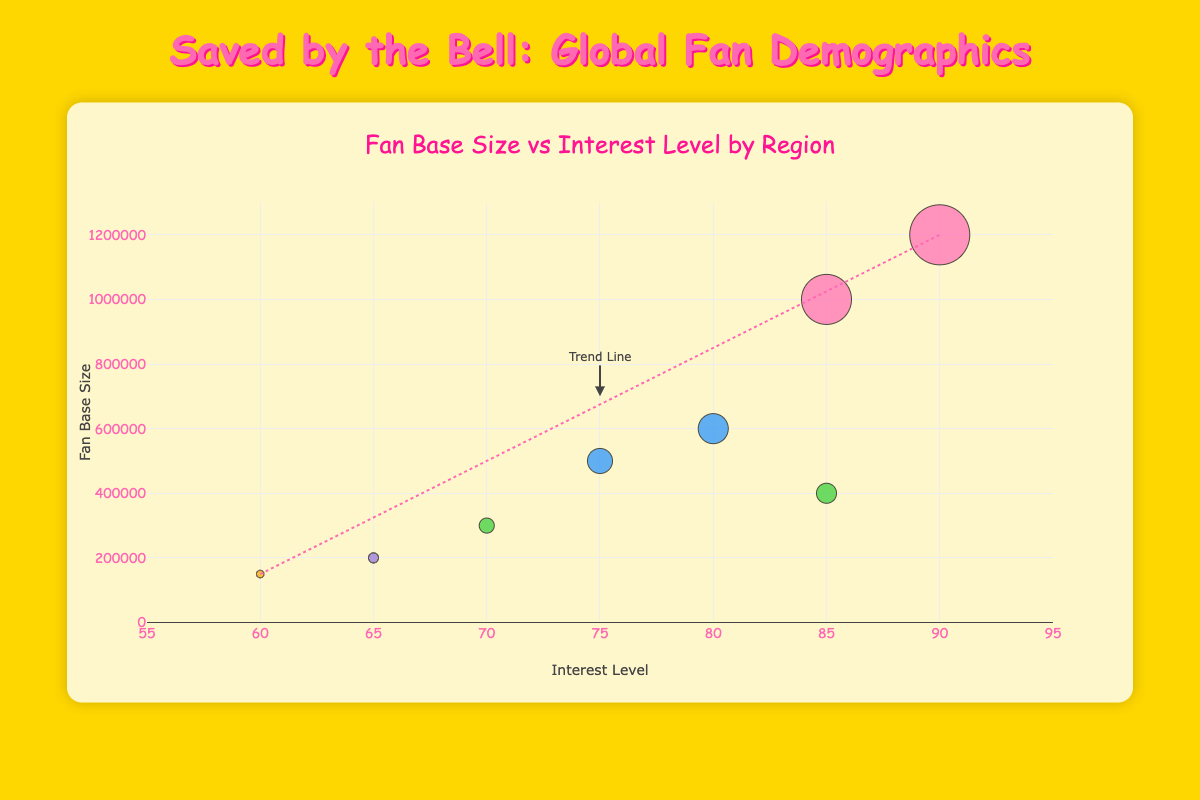How many countries are represented in the fan demographics chart? There are four countries represented in the fan demographics chart: United States, United Kingdom, Japan, and Brazil. There is also a fifth region, Oceania, but it is represented by Australia, a country.
Answer: 5 Which region has the highest interest level, and what is that level? North America has the highest interest level, which is 90, represented by females aged 18-24 in the United States.
Answer: North America, 90 What is the fan base size for the country with the lowest interest level in the chart? Australia has the lowest interest level at 60, and the fan base size for that country is 150,000.
Answer: 150,000 Which gender has a higher interest level in the United Kingdom? Females in the United Kingdom have a higher interest level of 80 than males, who have an interest level of 75.
Answer: Female Compare the interest levels between the 18-24 age group in the United States and Japan. Which group has higher interest, and by how much? The 18-24 age group in the United States has an interest level of 90 for females and 85 for males, while Japan has an interest level of 70 for males. The highest interest level in this age group is in the United States, which is 20 points higher than Japan (90 vs 70).
Answer: United States, 20 Identify the relationship between interest level and fan base size by describing the trend line in the chart. The trend line appears to show a positive correlation, indicating that as the interest level increases, the fan base size tends to increase as well.
Answer: Positive Correlation What is the combined fan base size for both male and female fans in the United Kingdom? In the United Kingdom, the male fan base size is 500,000 and the female fan base size is 600,000. Combined, the total fan base size is 500,000 + 600,000 = 1,100,000.
Answer: 1,100,000 Which country has the least represented fan base size, and what is its associated interest level? Australia has the least represented fan base size of 150,000 and its associated interest level is 60.
Answer: Australia, 60 